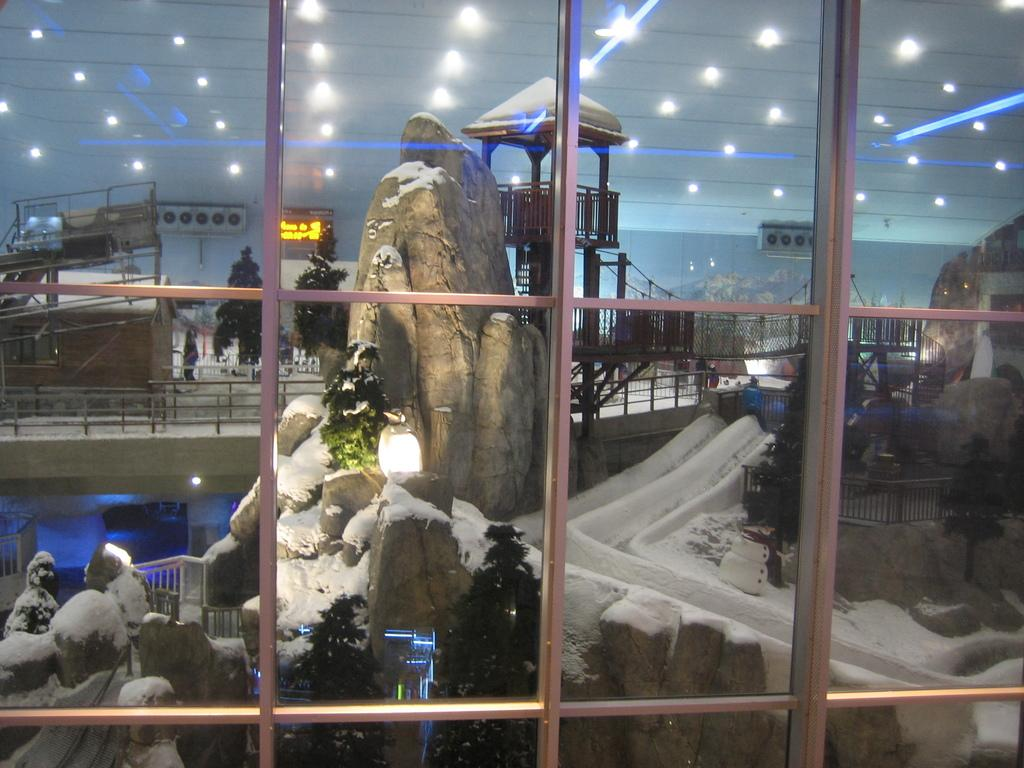What is located in the foreground of the image? There is a glass in the foreground of the image. What can be seen in the background of the image? In the background of the image, there are rocks, snow, a wall, railings, trees, and many other objects. What is the source of illumination at the top of the image? Lights are visible at the top of the image. How does the development of the trees in the image compare to the growth of the rocks? There is no comparison between the development of trees and the growth of rocks in the image, as rocks do not grow or develop like living organisms. 